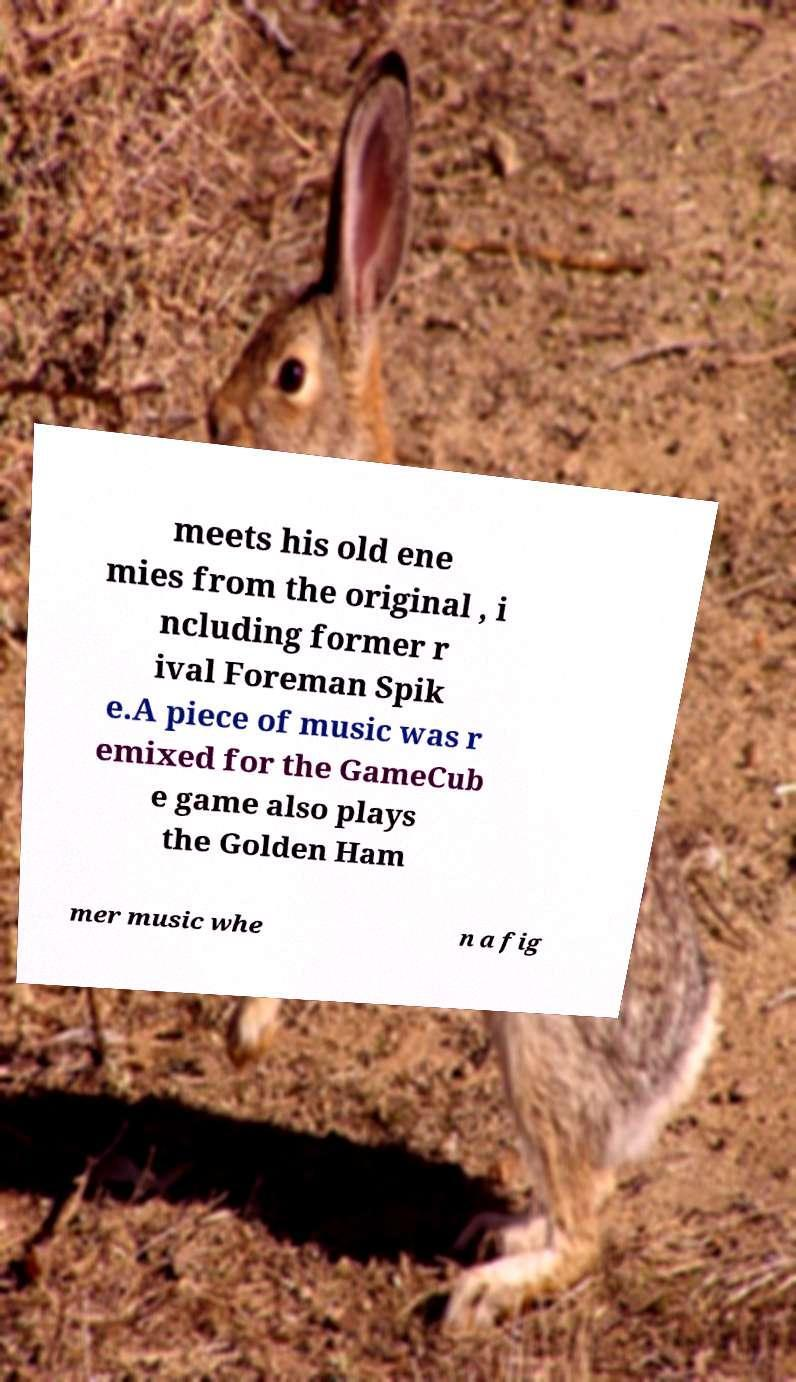I need the written content from this picture converted into text. Can you do that? meets his old ene mies from the original , i ncluding former r ival Foreman Spik e.A piece of music was r emixed for the GameCub e game also plays the Golden Ham mer music whe n a fig 